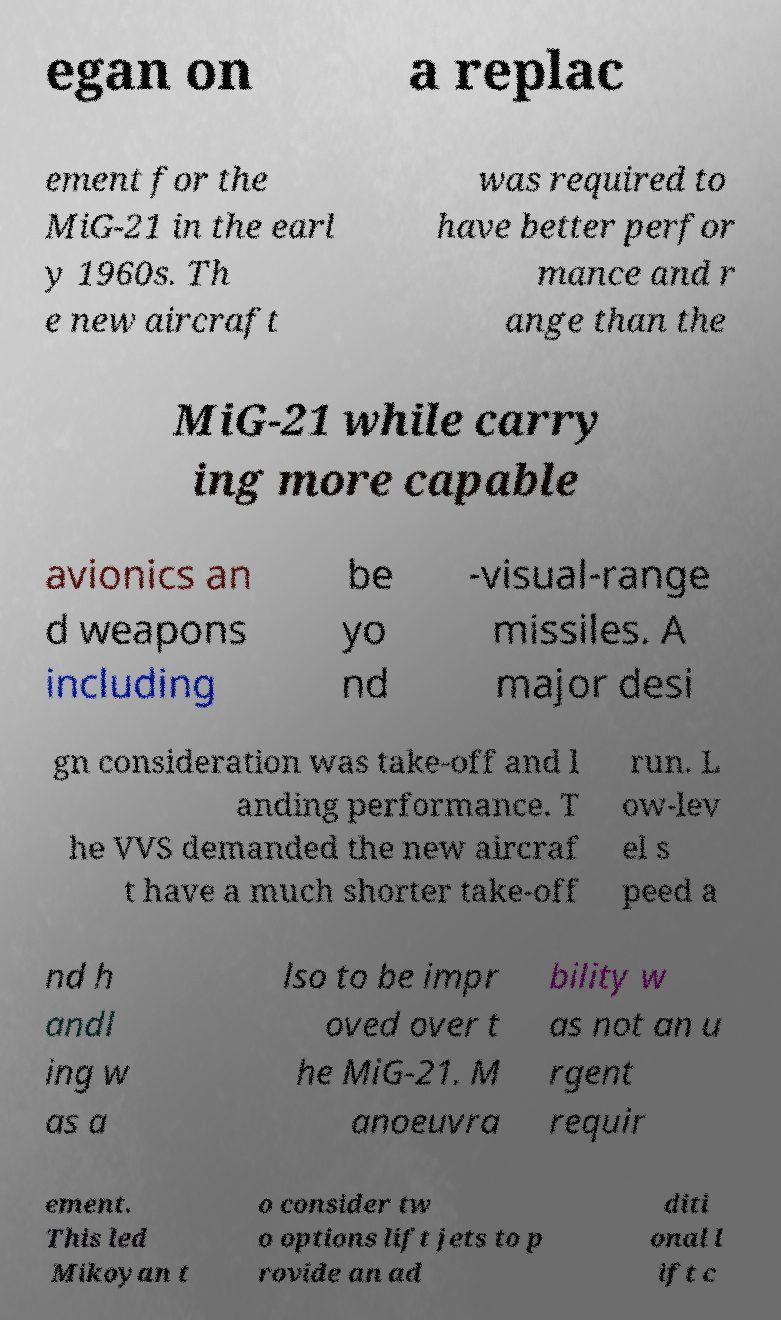Can you accurately transcribe the text from the provided image for me? egan on a replac ement for the MiG-21 in the earl y 1960s. Th e new aircraft was required to have better perfor mance and r ange than the MiG-21 while carry ing more capable avionics an d weapons including be yo nd -visual-range missiles. A major desi gn consideration was take-off and l anding performance. T he VVS demanded the new aircraf t have a much shorter take-off run. L ow-lev el s peed a nd h andl ing w as a lso to be impr oved over t he MiG-21. M anoeuvra bility w as not an u rgent requir ement. This led Mikoyan t o consider tw o options lift jets to p rovide an ad diti onal l ift c 